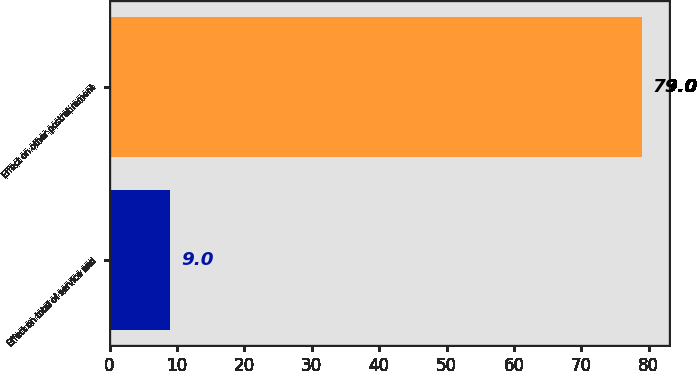<chart> <loc_0><loc_0><loc_500><loc_500><bar_chart><fcel>Effect on total of service and<fcel>Effect on other postretirement<nl><fcel>9<fcel>79<nl></chart> 